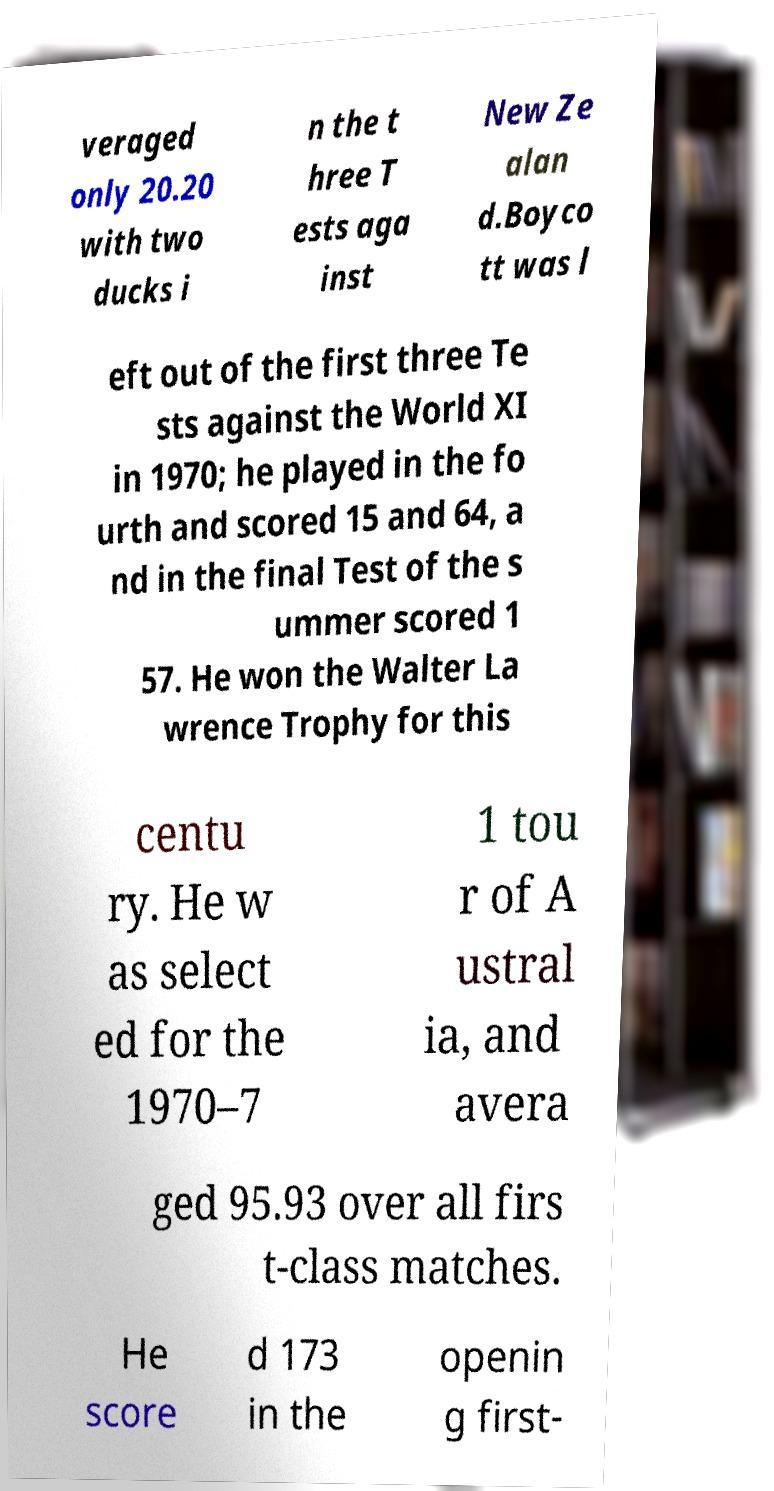Could you assist in decoding the text presented in this image and type it out clearly? veraged only 20.20 with two ducks i n the t hree T ests aga inst New Ze alan d.Boyco tt was l eft out of the first three Te sts against the World XI in 1970; he played in the fo urth and scored 15 and 64, a nd in the final Test of the s ummer scored 1 57. He won the Walter La wrence Trophy for this centu ry. He w as select ed for the 1970–7 1 tou r of A ustral ia, and avera ged 95.93 over all firs t-class matches. He score d 173 in the openin g first- 